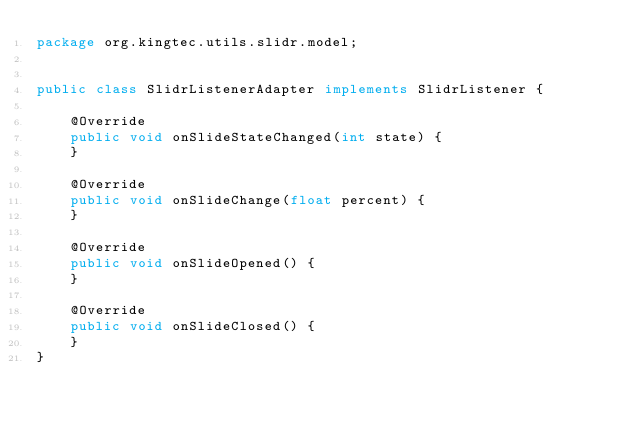<code> <loc_0><loc_0><loc_500><loc_500><_Java_>package org.kingtec.utils.slidr.model;


public class SlidrListenerAdapter implements SlidrListener {

    @Override
    public void onSlideStateChanged(int state) {
    }

    @Override
    public void onSlideChange(float percent) {
    }

    @Override
    public void onSlideOpened() {
    }

    @Override
    public void onSlideClosed() {
    }
}
</code> 